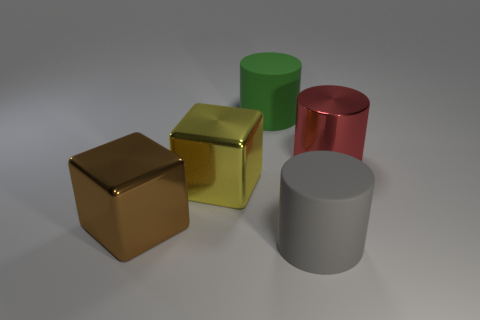Subtract all large gray rubber cylinders. How many cylinders are left? 2 Subtract all green cylinders. How many cylinders are left? 2 Add 4 tiny brown objects. How many objects exist? 9 Subtract 1 blocks. How many blocks are left? 1 Subtract all cubes. How many objects are left? 3 Subtract all matte things. Subtract all large gray rubber objects. How many objects are left? 2 Add 4 big brown shiny things. How many big brown shiny things are left? 5 Add 5 small blue cylinders. How many small blue cylinders exist? 5 Subtract 1 yellow cubes. How many objects are left? 4 Subtract all cyan cubes. Subtract all blue spheres. How many cubes are left? 2 